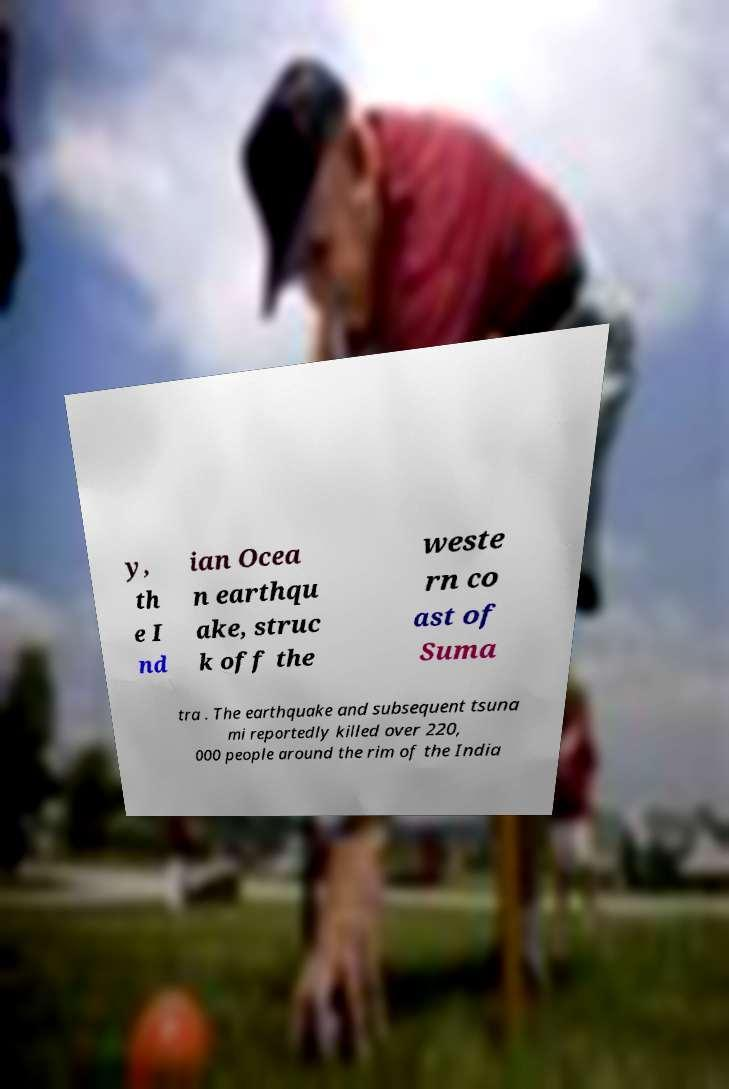Could you extract and type out the text from this image? y, th e I nd ian Ocea n earthqu ake, struc k off the weste rn co ast of Suma tra . The earthquake and subsequent tsuna mi reportedly killed over 220, 000 people around the rim of the India 